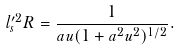<formula> <loc_0><loc_0><loc_500><loc_500>l _ { s } ^ { \prime 2 } R = \frac { 1 } { a u ( 1 + a ^ { 2 } u ^ { 2 } ) ^ { 1 / 2 } } .</formula> 